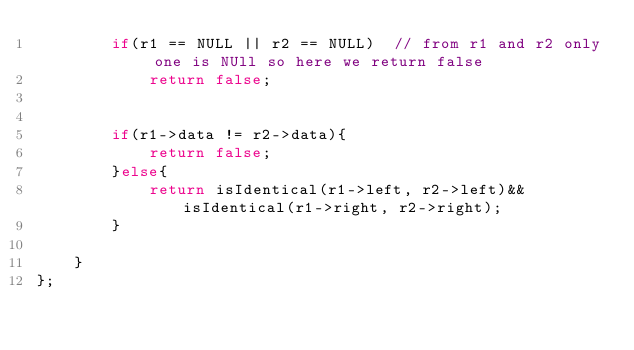Convert code to text. <code><loc_0><loc_0><loc_500><loc_500><_C++_>        if(r1 == NULL || r2 == NULL)  // from r1 and r2 only one is NUll so here we return false
            return false;
        
            
        if(r1->data != r2->data){
            return false;
        }else{
            return isIdentical(r1->left, r2->left)&& isIdentical(r1->right, r2->right);
        }
        
    }
};</code> 